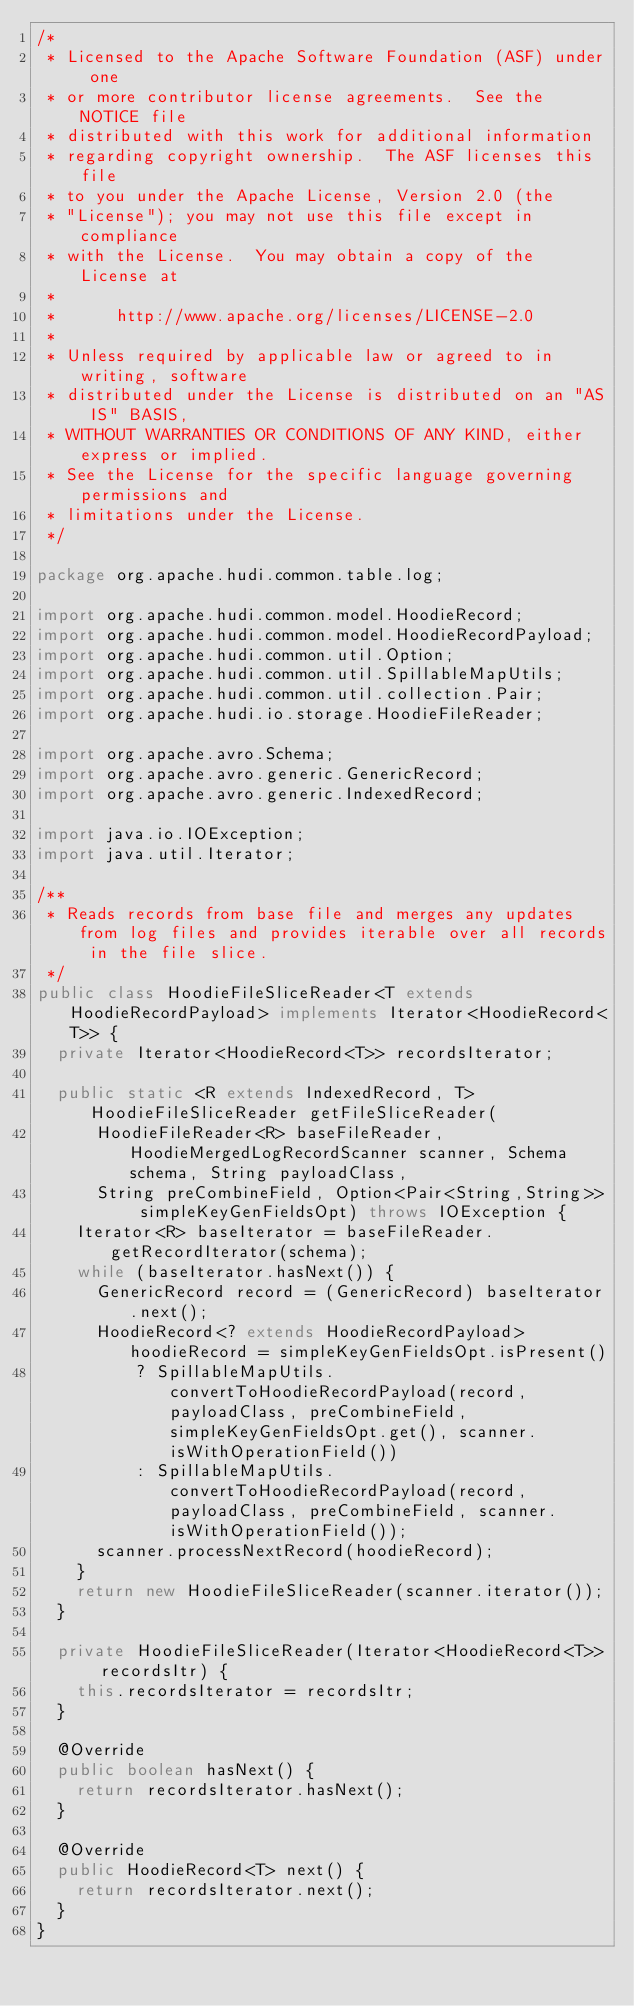<code> <loc_0><loc_0><loc_500><loc_500><_Java_>/*
 * Licensed to the Apache Software Foundation (ASF) under one
 * or more contributor license agreements.  See the NOTICE file
 * distributed with this work for additional information
 * regarding copyright ownership.  The ASF licenses this file
 * to you under the Apache License, Version 2.0 (the
 * "License"); you may not use this file except in compliance
 * with the License.  You may obtain a copy of the License at
 *
 *      http://www.apache.org/licenses/LICENSE-2.0
 *
 * Unless required by applicable law or agreed to in writing, software
 * distributed under the License is distributed on an "AS IS" BASIS,
 * WITHOUT WARRANTIES OR CONDITIONS OF ANY KIND, either express or implied.
 * See the License for the specific language governing permissions and
 * limitations under the License.
 */

package org.apache.hudi.common.table.log;

import org.apache.hudi.common.model.HoodieRecord;
import org.apache.hudi.common.model.HoodieRecordPayload;
import org.apache.hudi.common.util.Option;
import org.apache.hudi.common.util.SpillableMapUtils;
import org.apache.hudi.common.util.collection.Pair;
import org.apache.hudi.io.storage.HoodieFileReader;

import org.apache.avro.Schema;
import org.apache.avro.generic.GenericRecord;
import org.apache.avro.generic.IndexedRecord;

import java.io.IOException;
import java.util.Iterator;

/**
 * Reads records from base file and merges any updates from log files and provides iterable over all records in the file slice.
 */
public class HoodieFileSliceReader<T extends HoodieRecordPayload> implements Iterator<HoodieRecord<T>> {
  private Iterator<HoodieRecord<T>> recordsIterator;

  public static <R extends IndexedRecord, T> HoodieFileSliceReader getFileSliceReader(
      HoodieFileReader<R> baseFileReader, HoodieMergedLogRecordScanner scanner, Schema schema, String payloadClass,
      String preCombineField, Option<Pair<String,String>> simpleKeyGenFieldsOpt) throws IOException {
    Iterator<R> baseIterator = baseFileReader.getRecordIterator(schema);
    while (baseIterator.hasNext()) {
      GenericRecord record = (GenericRecord) baseIterator.next();
      HoodieRecord<? extends HoodieRecordPayload> hoodieRecord = simpleKeyGenFieldsOpt.isPresent()
          ? SpillableMapUtils.convertToHoodieRecordPayload(record, payloadClass, preCombineField, simpleKeyGenFieldsOpt.get(), scanner.isWithOperationField())
          : SpillableMapUtils.convertToHoodieRecordPayload(record, payloadClass, preCombineField, scanner.isWithOperationField());
      scanner.processNextRecord(hoodieRecord);
    }
    return new HoodieFileSliceReader(scanner.iterator());
  }

  private HoodieFileSliceReader(Iterator<HoodieRecord<T>> recordsItr) {
    this.recordsIterator = recordsItr;
  }

  @Override
  public boolean hasNext() {
    return recordsIterator.hasNext();
  }

  @Override
  public HoodieRecord<T> next() {
    return recordsIterator.next();
  }
}
</code> 